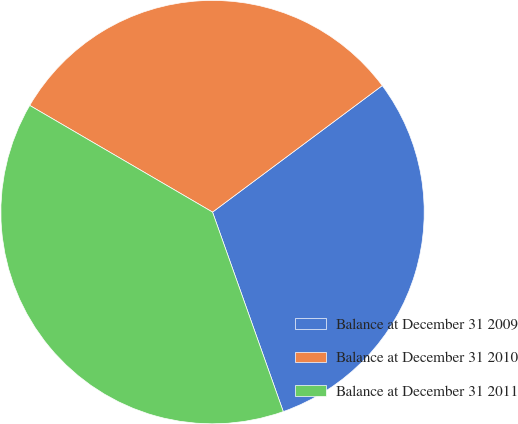<chart> <loc_0><loc_0><loc_500><loc_500><pie_chart><fcel>Balance at December 31 2009<fcel>Balance at December 31 2010<fcel>Balance at December 31 2011<nl><fcel>29.77%<fcel>31.4%<fcel>38.83%<nl></chart> 